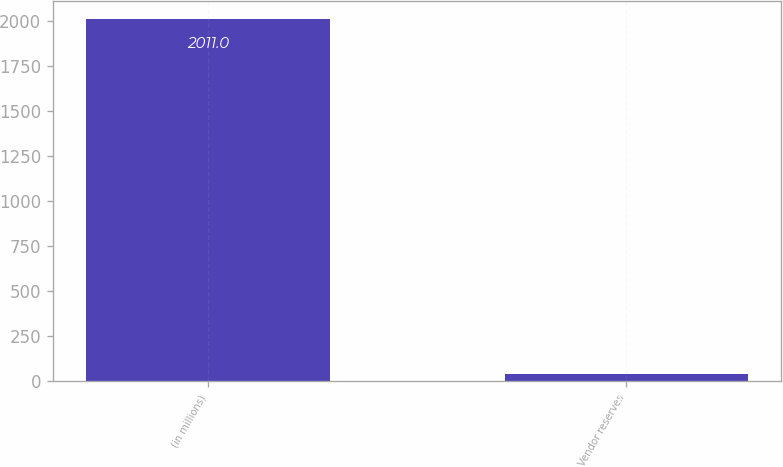Convert chart to OTSL. <chart><loc_0><loc_0><loc_500><loc_500><bar_chart><fcel>(in millions)<fcel>Vendor reserves<nl><fcel>2011<fcel>41<nl></chart> 